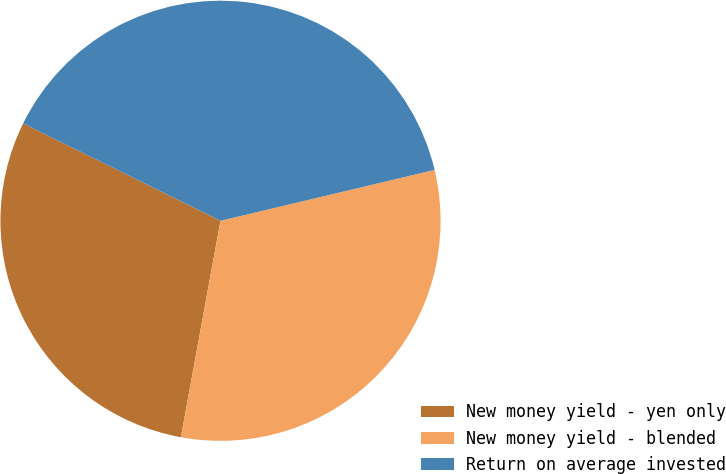Convert chart. <chart><loc_0><loc_0><loc_500><loc_500><pie_chart><fcel>New money yield - yen only<fcel>New money yield - blended<fcel>Return on average invested<nl><fcel>29.41%<fcel>31.59%<fcel>38.99%<nl></chart> 